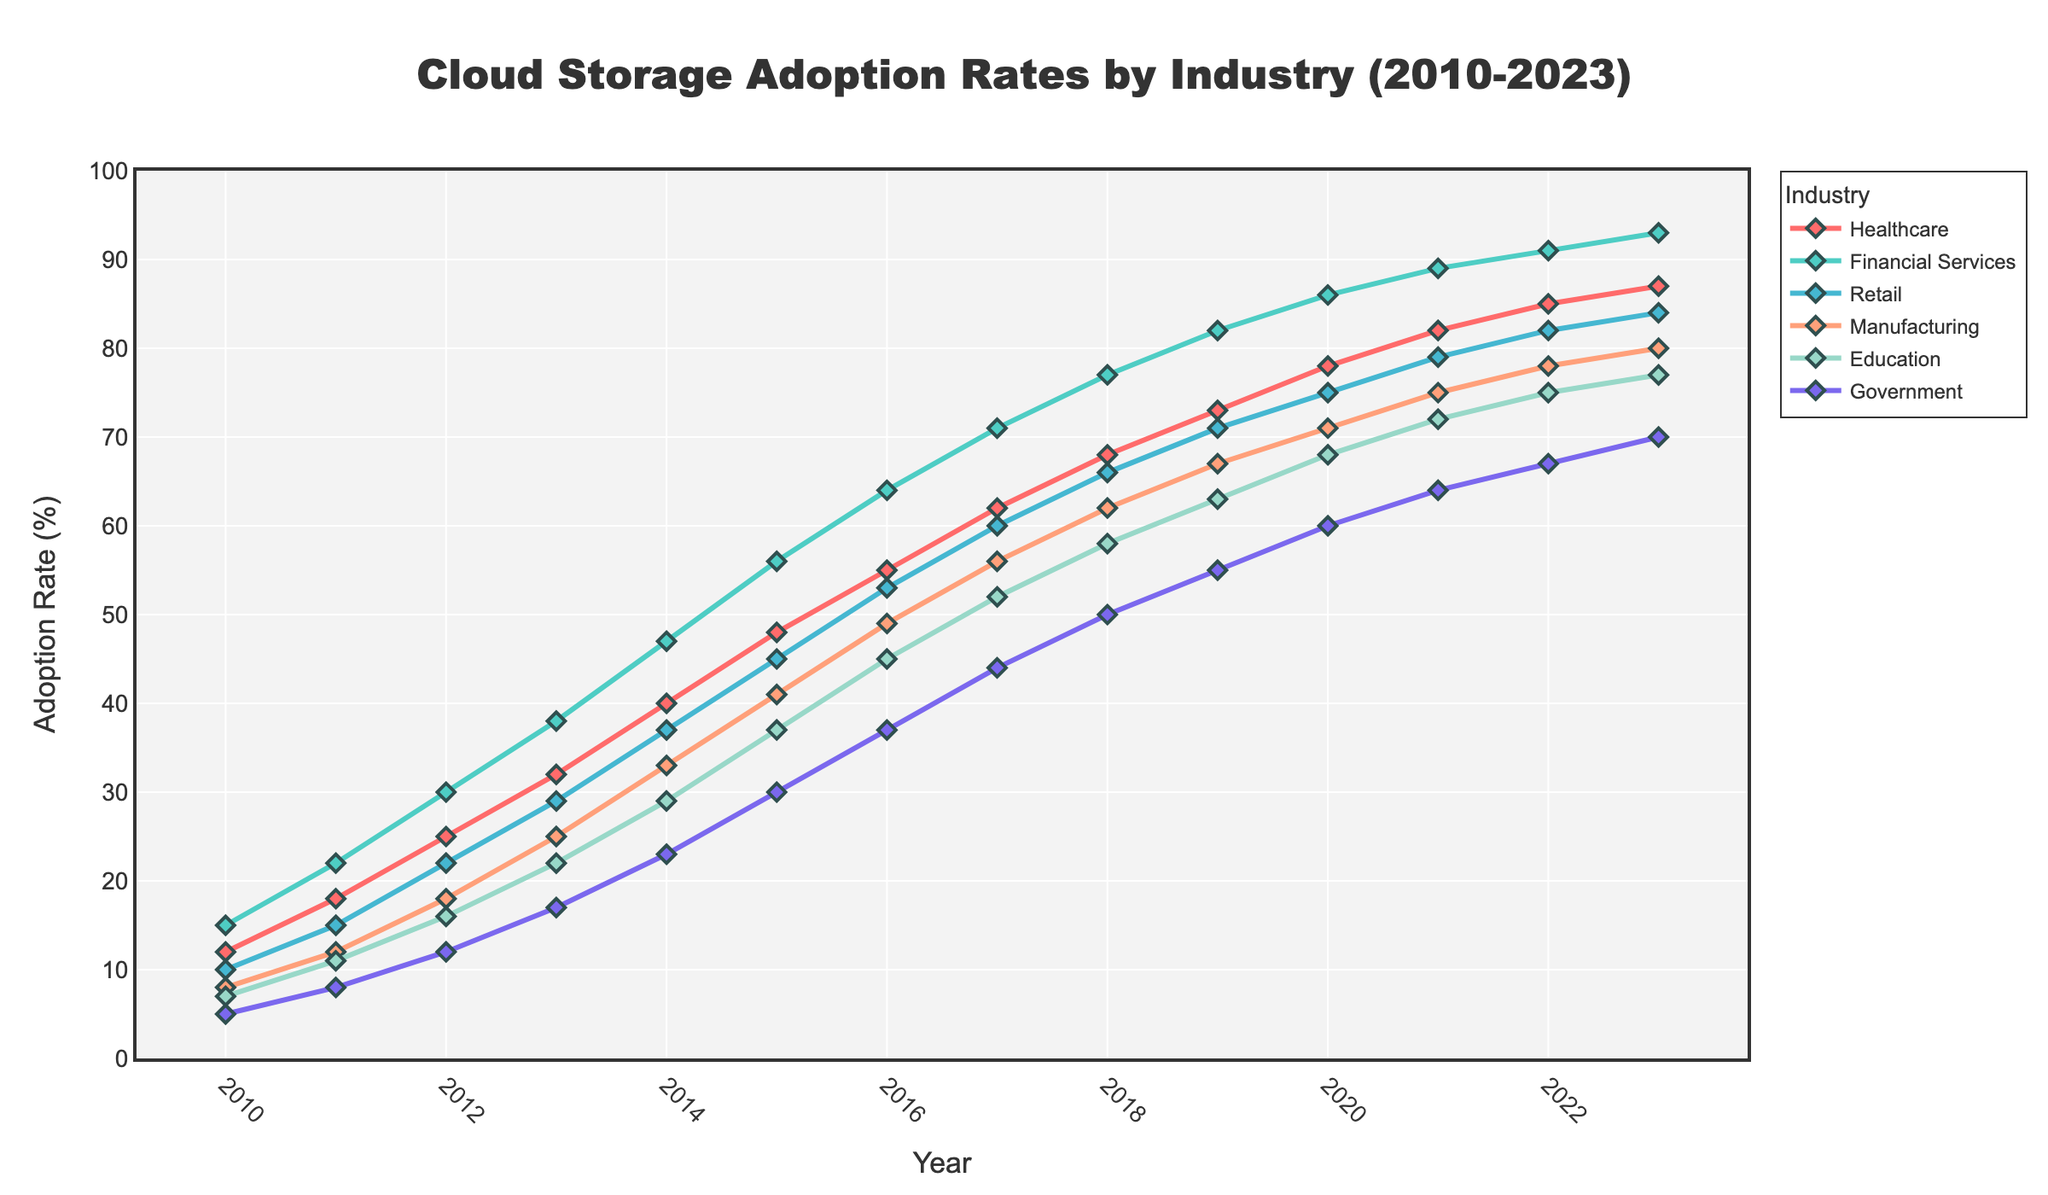What is the adoption rate of cloud storage in Education in 2023? To find this, look at the point in 2023 on the line representing the Education industry.
Answer: 77 Between which years did the Healthcare industry see the highest increase in cloud storage adoption rate? Observe the slope of the Healthcare line between each pair of consecutive years and identify the steepest slope.
Answer: 2010 to 2011 How much did the adoption rate for the Financial Services sector increase from 2015 to 2020? Subtract the adoption rate in 2015 from that in 2020 for Financial Services (86 - 56).
Answer: 30 Which industry had the lowest adoption rate in 2018? Compare the adoption rates of all industries at the year 2018 and find the lowest value.
Answer: Government By how many percentage points did the adoption rate of Retail increase from 2012 to 2013? Subtract the 2012 adoption rate from the 2013 rate for Retail (29 - 22).
Answer: 7 Which industry had the most consistent growth in terms of adoption rate from 2010 to 2023? Analyze the lines and identify which industry shows the most uniform increase over the years.
Answer: Financial Services In which year did the Government sector’s cloud storage adoption rate hit 50%? Locate where the line for Government intersects with the y-axis at 50% and identify the corresponding year.
Answer: 2018 Compare the adoption rate of cloud storage in Manufacturing and Retail in 2015. Which industry has a higher rate and by how much? Subtract the adoption rate of Manufacturing from Retail in 2015 (45 - 41).
Answer: Retail by 4 What is the average adoption rate of cloud storage for the Education sector from 2010 to 2023? Sum all the adoption rates for Education from 2010 to 2023 and divide by the total number of years (7+11+16+22+29+37+45+52+58+63+68+72+75+77, then divide by 14).
Answer: 45.57 By how much did the adoption rate in Financial Services increase from 2019 to 2023? Subtract the 2019 adoption rate from the 2023 adoption rate for Financial Services (93 - 82).
Answer: 11 